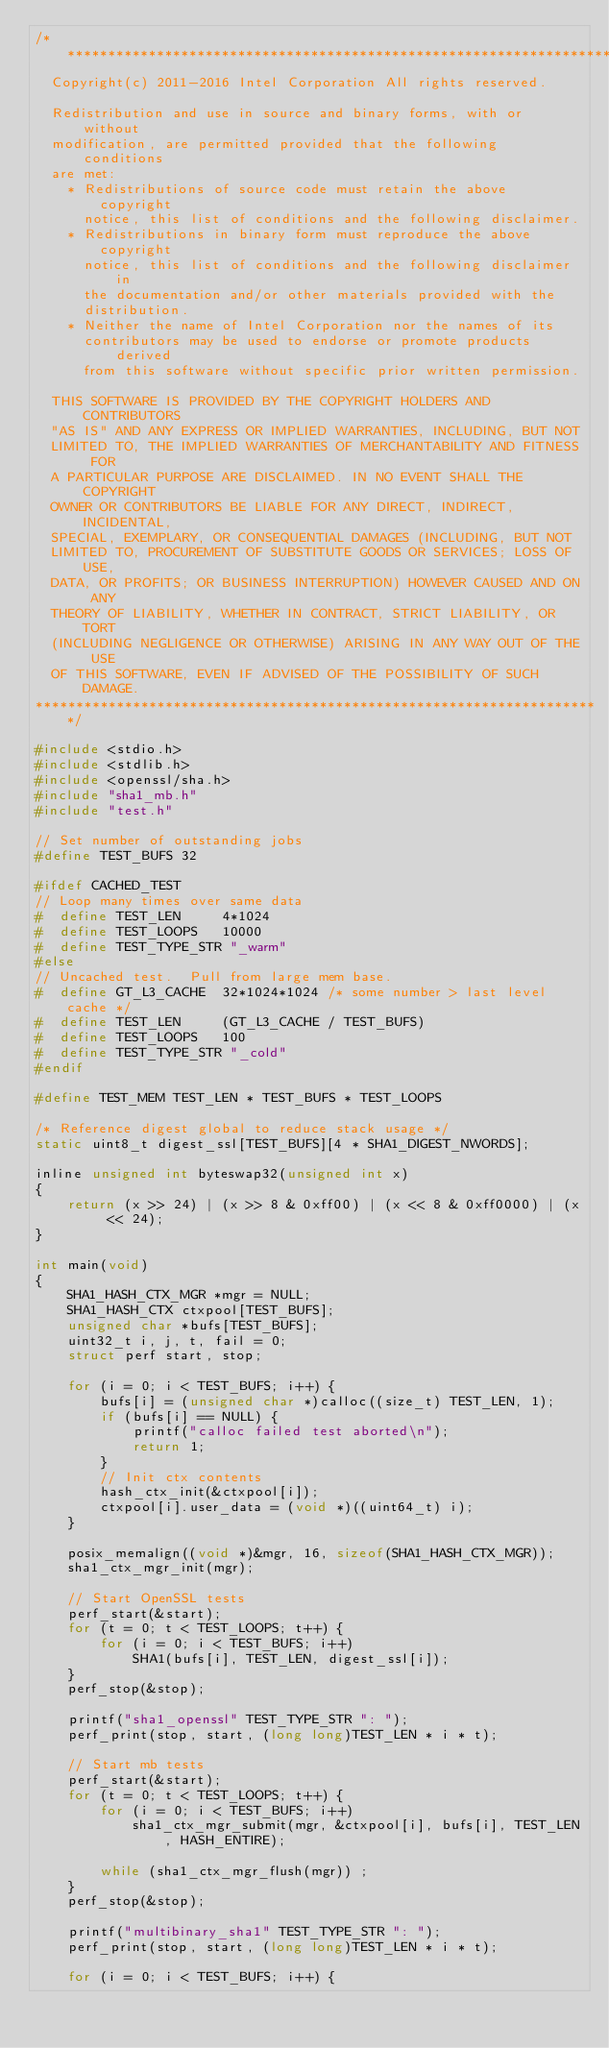Convert code to text. <code><loc_0><loc_0><loc_500><loc_500><_C_>/**********************************************************************
  Copyright(c) 2011-2016 Intel Corporation All rights reserved.

  Redistribution and use in source and binary forms, with or without
  modification, are permitted provided that the following conditions
  are met:
    * Redistributions of source code must retain the above copyright
      notice, this list of conditions and the following disclaimer.
    * Redistributions in binary form must reproduce the above copyright
      notice, this list of conditions and the following disclaimer in
      the documentation and/or other materials provided with the
      distribution.
    * Neither the name of Intel Corporation nor the names of its
      contributors may be used to endorse or promote products derived
      from this software without specific prior written permission.

  THIS SOFTWARE IS PROVIDED BY THE COPYRIGHT HOLDERS AND CONTRIBUTORS
  "AS IS" AND ANY EXPRESS OR IMPLIED WARRANTIES, INCLUDING, BUT NOT
  LIMITED TO, THE IMPLIED WARRANTIES OF MERCHANTABILITY AND FITNESS FOR
  A PARTICULAR PURPOSE ARE DISCLAIMED. IN NO EVENT SHALL THE COPYRIGHT
  OWNER OR CONTRIBUTORS BE LIABLE FOR ANY DIRECT, INDIRECT, INCIDENTAL,
  SPECIAL, EXEMPLARY, OR CONSEQUENTIAL DAMAGES (INCLUDING, BUT NOT
  LIMITED TO, PROCUREMENT OF SUBSTITUTE GOODS OR SERVICES; LOSS OF USE,
  DATA, OR PROFITS; OR BUSINESS INTERRUPTION) HOWEVER CAUSED AND ON ANY
  THEORY OF LIABILITY, WHETHER IN CONTRACT, STRICT LIABILITY, OR TORT
  (INCLUDING NEGLIGENCE OR OTHERWISE) ARISING IN ANY WAY OUT OF THE USE
  OF THIS SOFTWARE, EVEN IF ADVISED OF THE POSSIBILITY OF SUCH DAMAGE.
**********************************************************************/

#include <stdio.h>
#include <stdlib.h>
#include <openssl/sha.h>
#include "sha1_mb.h"
#include "test.h"

// Set number of outstanding jobs
#define TEST_BUFS 32

#ifdef CACHED_TEST
// Loop many times over same data
#  define TEST_LEN     4*1024
#  define TEST_LOOPS   10000
#  define TEST_TYPE_STR "_warm"
#else
// Uncached test.  Pull from large mem base.
#  define GT_L3_CACHE  32*1024*1024	/* some number > last level cache */
#  define TEST_LEN     (GT_L3_CACHE / TEST_BUFS)
#  define TEST_LOOPS   100
#  define TEST_TYPE_STR "_cold"
#endif

#define TEST_MEM TEST_LEN * TEST_BUFS * TEST_LOOPS

/* Reference digest global to reduce stack usage */
static uint8_t digest_ssl[TEST_BUFS][4 * SHA1_DIGEST_NWORDS];

inline unsigned int byteswap32(unsigned int x)
{
	return (x >> 24) | (x >> 8 & 0xff00) | (x << 8 & 0xff0000) | (x << 24);
}

int main(void)
{
	SHA1_HASH_CTX_MGR *mgr = NULL;
	SHA1_HASH_CTX ctxpool[TEST_BUFS];
	unsigned char *bufs[TEST_BUFS];
	uint32_t i, j, t, fail = 0;
	struct perf start, stop;

	for (i = 0; i < TEST_BUFS; i++) {
		bufs[i] = (unsigned char *)calloc((size_t) TEST_LEN, 1);
		if (bufs[i] == NULL) {
			printf("calloc failed test aborted\n");
			return 1;
		}
		// Init ctx contents
		hash_ctx_init(&ctxpool[i]);
		ctxpool[i].user_data = (void *)((uint64_t) i);
	}

	posix_memalign((void *)&mgr, 16, sizeof(SHA1_HASH_CTX_MGR));
	sha1_ctx_mgr_init(mgr);

	// Start OpenSSL tests
	perf_start(&start);
	for (t = 0; t < TEST_LOOPS; t++) {
		for (i = 0; i < TEST_BUFS; i++)
			SHA1(bufs[i], TEST_LEN, digest_ssl[i]);
	}
	perf_stop(&stop);

	printf("sha1_openssl" TEST_TYPE_STR ": ");
	perf_print(stop, start, (long long)TEST_LEN * i * t);

	// Start mb tests
	perf_start(&start);
	for (t = 0; t < TEST_LOOPS; t++) {
		for (i = 0; i < TEST_BUFS; i++)
			sha1_ctx_mgr_submit(mgr, &ctxpool[i], bufs[i], TEST_LEN, HASH_ENTIRE);

		while (sha1_ctx_mgr_flush(mgr)) ;
	}
	perf_stop(&stop);

	printf("multibinary_sha1" TEST_TYPE_STR ": ");
	perf_print(stop, start, (long long)TEST_LEN * i * t);

	for (i = 0; i < TEST_BUFS; i++) {</code> 